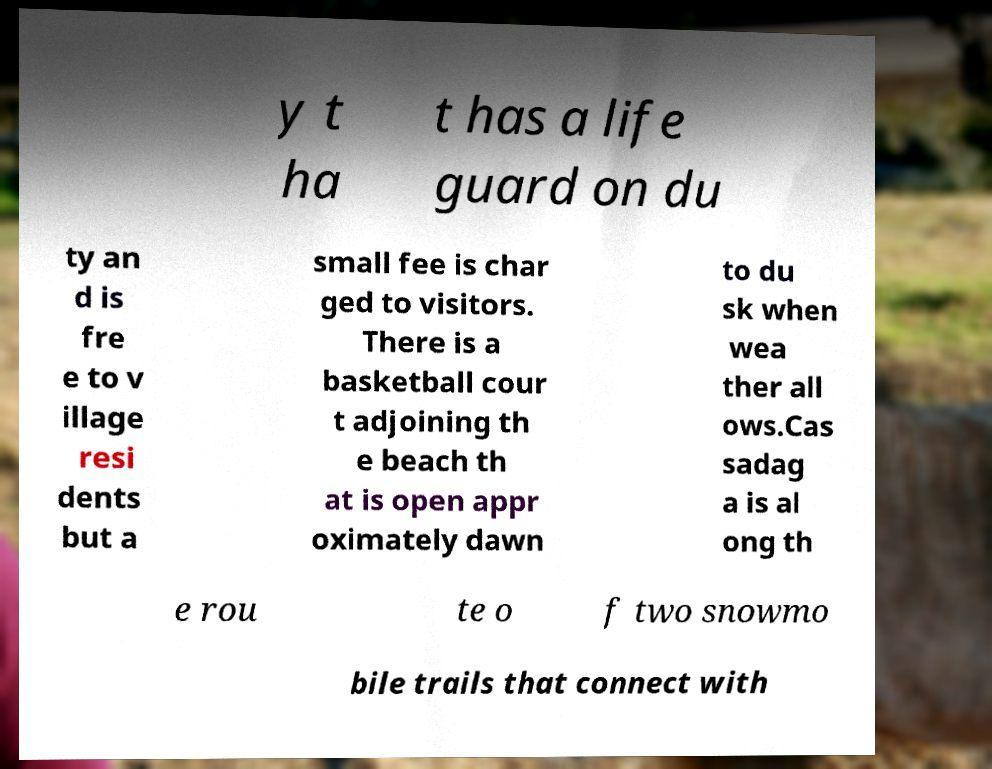For documentation purposes, I need the text within this image transcribed. Could you provide that? y t ha t has a life guard on du ty an d is fre e to v illage resi dents but a small fee is char ged to visitors. There is a basketball cour t adjoining th e beach th at is open appr oximately dawn to du sk when wea ther all ows.Cas sadag a is al ong th e rou te o f two snowmo bile trails that connect with 